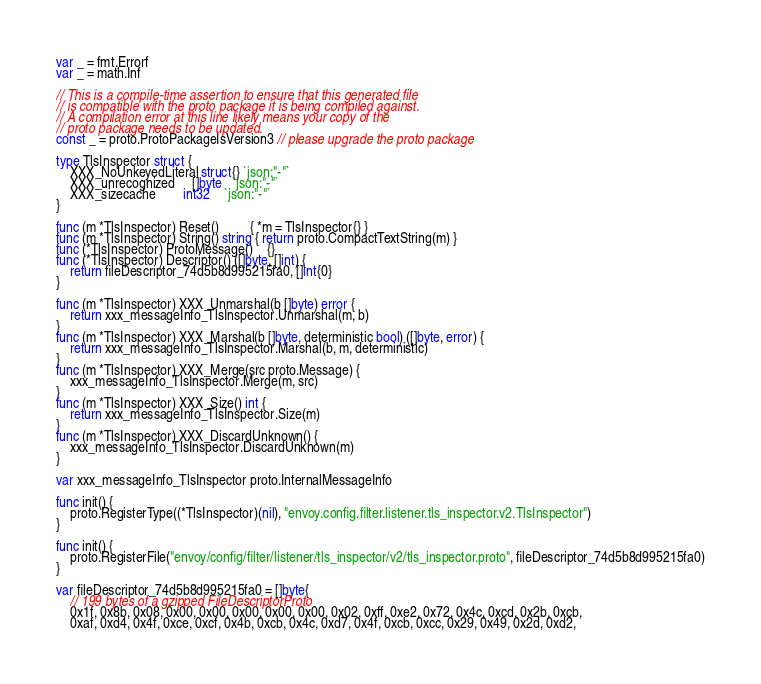<code> <loc_0><loc_0><loc_500><loc_500><_Go_>var _ = fmt.Errorf
var _ = math.Inf

// This is a compile-time assertion to ensure that this generated file
// is compatible with the proto package it is being compiled against.
// A compilation error at this line likely means your copy of the
// proto package needs to be updated.
const _ = proto.ProtoPackageIsVersion3 // please upgrade the proto package

type TlsInspector struct {
	XXX_NoUnkeyedLiteral struct{} `json:"-"`
	XXX_unrecognized     []byte   `json:"-"`
	XXX_sizecache        int32    `json:"-"`
}

func (m *TlsInspector) Reset()         { *m = TlsInspector{} }
func (m *TlsInspector) String() string { return proto.CompactTextString(m) }
func (*TlsInspector) ProtoMessage()    {}
func (*TlsInspector) Descriptor() ([]byte, []int) {
	return fileDescriptor_74d5b8d995215fa0, []int{0}
}

func (m *TlsInspector) XXX_Unmarshal(b []byte) error {
	return xxx_messageInfo_TlsInspector.Unmarshal(m, b)
}
func (m *TlsInspector) XXX_Marshal(b []byte, deterministic bool) ([]byte, error) {
	return xxx_messageInfo_TlsInspector.Marshal(b, m, deterministic)
}
func (m *TlsInspector) XXX_Merge(src proto.Message) {
	xxx_messageInfo_TlsInspector.Merge(m, src)
}
func (m *TlsInspector) XXX_Size() int {
	return xxx_messageInfo_TlsInspector.Size(m)
}
func (m *TlsInspector) XXX_DiscardUnknown() {
	xxx_messageInfo_TlsInspector.DiscardUnknown(m)
}

var xxx_messageInfo_TlsInspector proto.InternalMessageInfo

func init() {
	proto.RegisterType((*TlsInspector)(nil), "envoy.config.filter.listener.tls_inspector.v2.TlsInspector")
}

func init() {
	proto.RegisterFile("envoy/config/filter/listener/tls_inspector/v2/tls_inspector.proto", fileDescriptor_74d5b8d995215fa0)
}

var fileDescriptor_74d5b8d995215fa0 = []byte{
	// 199 bytes of a gzipped FileDescriptorProto
	0x1f, 0x8b, 0x08, 0x00, 0x00, 0x00, 0x00, 0x00, 0x02, 0xff, 0xe2, 0x72, 0x4c, 0xcd, 0x2b, 0xcb,
	0xaf, 0xd4, 0x4f, 0xce, 0xcf, 0x4b, 0xcb, 0x4c, 0xd7, 0x4f, 0xcb, 0xcc, 0x29, 0x49, 0x2d, 0xd2,</code> 